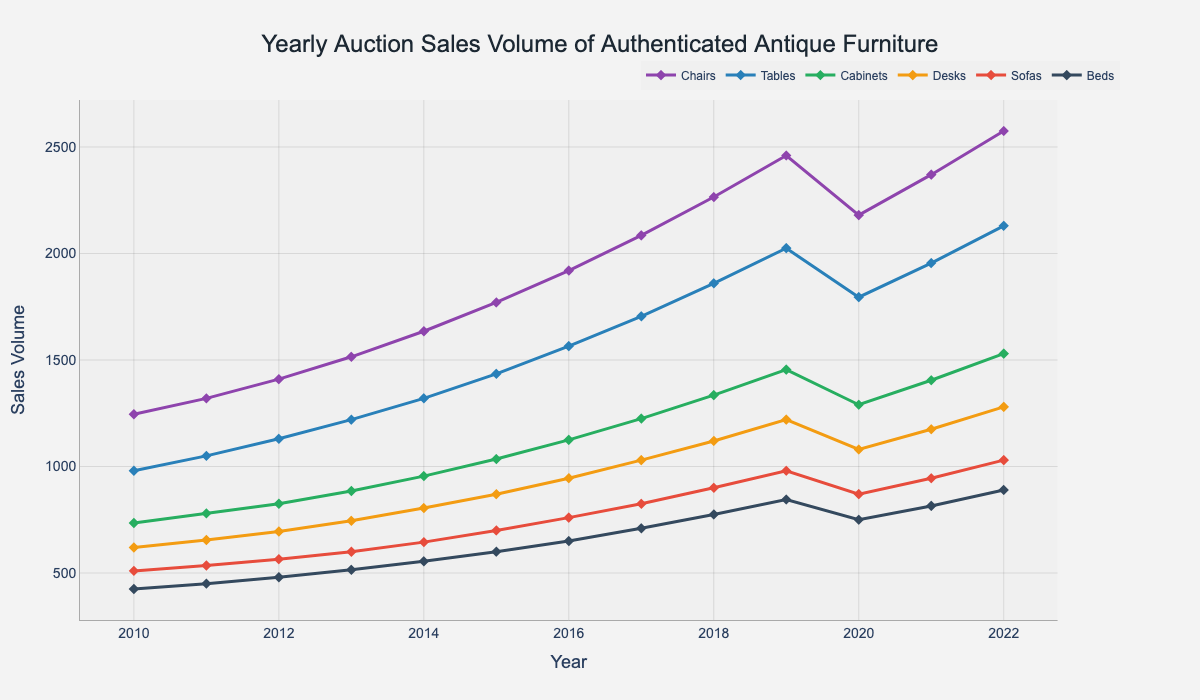What's the trend for the sales volume of Chairs from 2010 to 2022? The sales volume of Chairs consistently increased from 1245 in 2010 to 2575 in 2022. This indicates a clear upward trend in demand or availability over the years.
Answer: Upward trend Which category had the highest sales volume in 2022? By examining the figure, we can see that Chairs had the highest sales volume in 2022 with 2575 units sold.
Answer: Chairs How did the sales volume of Sofas change from 2015 to 2020? The sales volume of Sofas increased from 700 in 2015 to 900 in 2018, then decreased to 870 in 2020. This indicates a rise followed by a slight decline.
Answer: Increased then decreased Which year's sales volume for Tables was closest to 1500 units? By observing the trend lines, the sales volume of Tables in 2019 was 1455, which is the closest to 1500 units compared to other years.
Answer: 2019 What's the average sales volume for Beds over the entire period? Summing up the sales volumes for Beds from 2010 to 2022 (425 + 450 + 480 + 515 + 555 + 600 + 650 + 710 + 775 + 845 + 750 + 815 + 890) gives 9450. Dividing by 13 (number of years) results in an average of approximately 727 units per year.
Answer: 727 Between which years did the sales volume for Desks increase the most? By comparing yearly increases, the largest increase occurred from 2017 (1030) to 2018 (1120), which is a change of 90 units.
Answer: 2017 to 2018 Which categories experienced a decline in sales volume from 2019 to 2020? According to the figure, Chairs, Tables, Cabinets, Desks, Sofas, and Beds all showed a decline in sales volumes in 2020 compared to 2019.
Answer: All categories For which category did the sales volume reach exactly 2000 units first? The trend lines reveal that Tables reached exactly 2000 units first in 2019.
Answer: Tables What's the total sales volume for Cabinets in 2015 and 2020 combined? Adding the sales volumes for Cabinets in 2015 (1035) and 2020 (1290) results in a total of 2325 units.
Answer: 2325 Which category had the smallest increase in sales volume from 2010 to 2022? Analyzing the difference between 2022 and 2010 sales volumes across all categories, the Beds category increased from 425 to 890, a difference of 465 units, which is the smallest increase among all categories.
Answer: Beds 